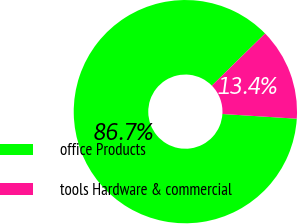<chart> <loc_0><loc_0><loc_500><loc_500><pie_chart><fcel>office Products<fcel>tools Hardware & commercial<nl><fcel>86.65%<fcel>13.35%<nl></chart> 